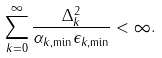Convert formula to latex. <formula><loc_0><loc_0><loc_500><loc_500>\sum _ { k = 0 } ^ { \infty } \frac { \Delta _ { k } ^ { 2 } } { \alpha _ { k , \min } \epsilon _ { k , \min } } < \infty .</formula> 